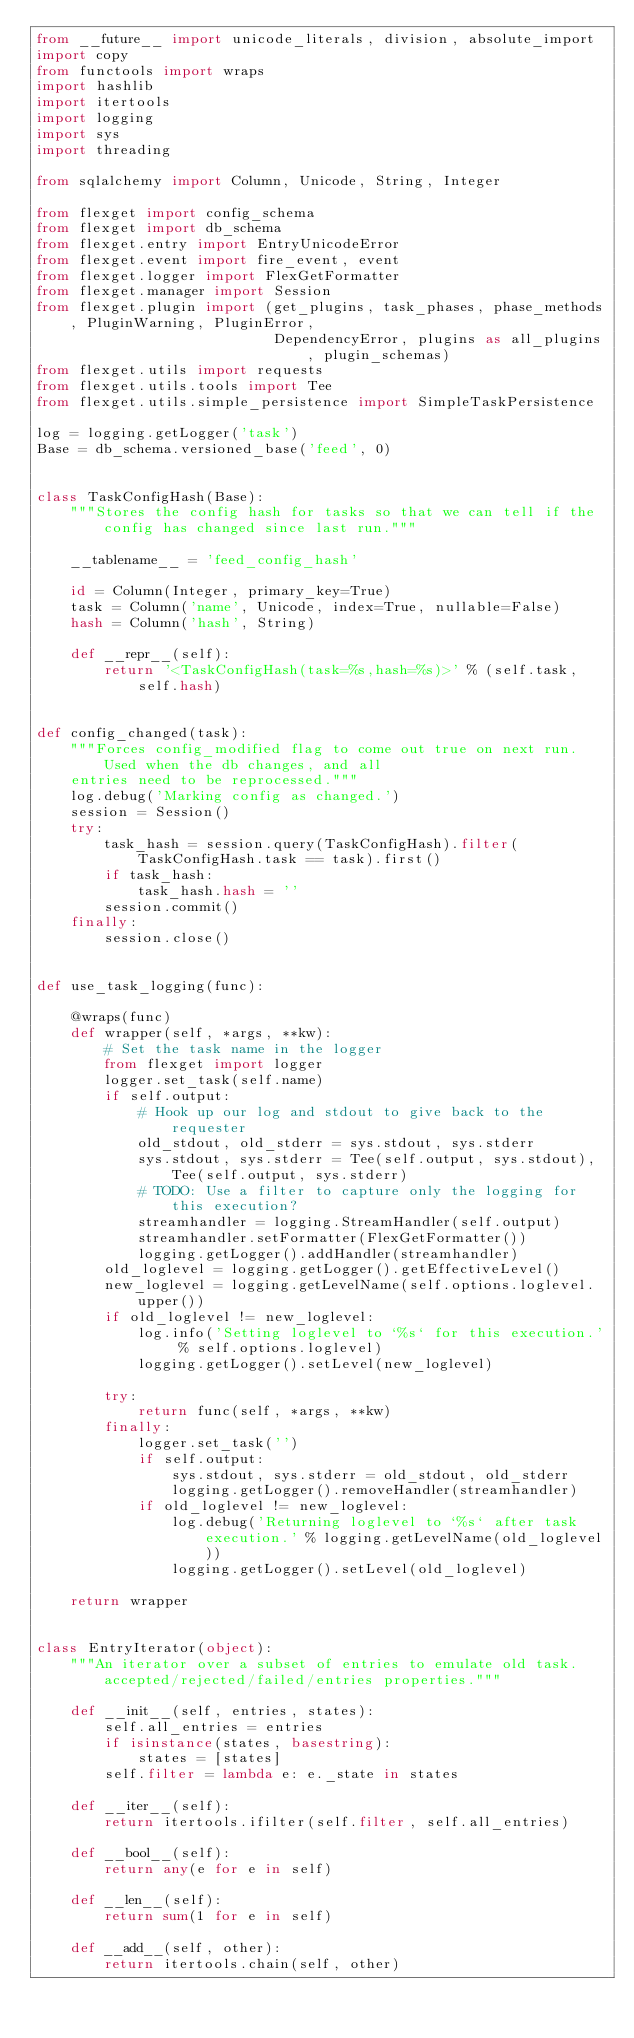<code> <loc_0><loc_0><loc_500><loc_500><_Python_>from __future__ import unicode_literals, division, absolute_import
import copy
from functools import wraps
import hashlib
import itertools
import logging
import sys
import threading

from sqlalchemy import Column, Unicode, String, Integer

from flexget import config_schema
from flexget import db_schema
from flexget.entry import EntryUnicodeError
from flexget.event import fire_event, event
from flexget.logger import FlexGetFormatter
from flexget.manager import Session
from flexget.plugin import (get_plugins, task_phases, phase_methods, PluginWarning, PluginError,
                            DependencyError, plugins as all_plugins, plugin_schemas)
from flexget.utils import requests
from flexget.utils.tools import Tee
from flexget.utils.simple_persistence import SimpleTaskPersistence

log = logging.getLogger('task')
Base = db_schema.versioned_base('feed', 0)


class TaskConfigHash(Base):
    """Stores the config hash for tasks so that we can tell if the config has changed since last run."""

    __tablename__ = 'feed_config_hash'

    id = Column(Integer, primary_key=True)
    task = Column('name', Unicode, index=True, nullable=False)
    hash = Column('hash', String)

    def __repr__(self):
        return '<TaskConfigHash(task=%s,hash=%s)>' % (self.task, self.hash)


def config_changed(task):
    """Forces config_modified flag to come out true on next run. Used when the db changes, and all
    entries need to be reprocessed."""
    log.debug('Marking config as changed.')
    session = Session()
    try:
        task_hash = session.query(TaskConfigHash).filter(TaskConfigHash.task == task).first()
        if task_hash:
            task_hash.hash = ''
        session.commit()
    finally:
        session.close()


def use_task_logging(func):

    @wraps(func)
    def wrapper(self, *args, **kw):
        # Set the task name in the logger
        from flexget import logger
        logger.set_task(self.name)
        if self.output:
            # Hook up our log and stdout to give back to the requester
            old_stdout, old_stderr = sys.stdout, sys.stderr
            sys.stdout, sys.stderr = Tee(self.output, sys.stdout), Tee(self.output, sys.stderr)
            # TODO: Use a filter to capture only the logging for this execution?
            streamhandler = logging.StreamHandler(self.output)
            streamhandler.setFormatter(FlexGetFormatter())
            logging.getLogger().addHandler(streamhandler)
        old_loglevel = logging.getLogger().getEffectiveLevel()
        new_loglevel = logging.getLevelName(self.options.loglevel.upper())
        if old_loglevel != new_loglevel:
            log.info('Setting loglevel to `%s` for this execution.' % self.options.loglevel)
            logging.getLogger().setLevel(new_loglevel)

        try:
            return func(self, *args, **kw)
        finally:
            logger.set_task('')
            if self.output:
                sys.stdout, sys.stderr = old_stdout, old_stderr
                logging.getLogger().removeHandler(streamhandler)
            if old_loglevel != new_loglevel:
                log.debug('Returning loglevel to `%s` after task execution.' % logging.getLevelName(old_loglevel))
                logging.getLogger().setLevel(old_loglevel)

    return wrapper


class EntryIterator(object):
    """An iterator over a subset of entries to emulate old task.accepted/rejected/failed/entries properties."""

    def __init__(self, entries, states):
        self.all_entries = entries
        if isinstance(states, basestring):
            states = [states]
        self.filter = lambda e: e._state in states

    def __iter__(self):
        return itertools.ifilter(self.filter, self.all_entries)

    def __bool__(self):
        return any(e for e in self)

    def __len__(self):
        return sum(1 for e in self)

    def __add__(self, other):
        return itertools.chain(self, other)
</code> 